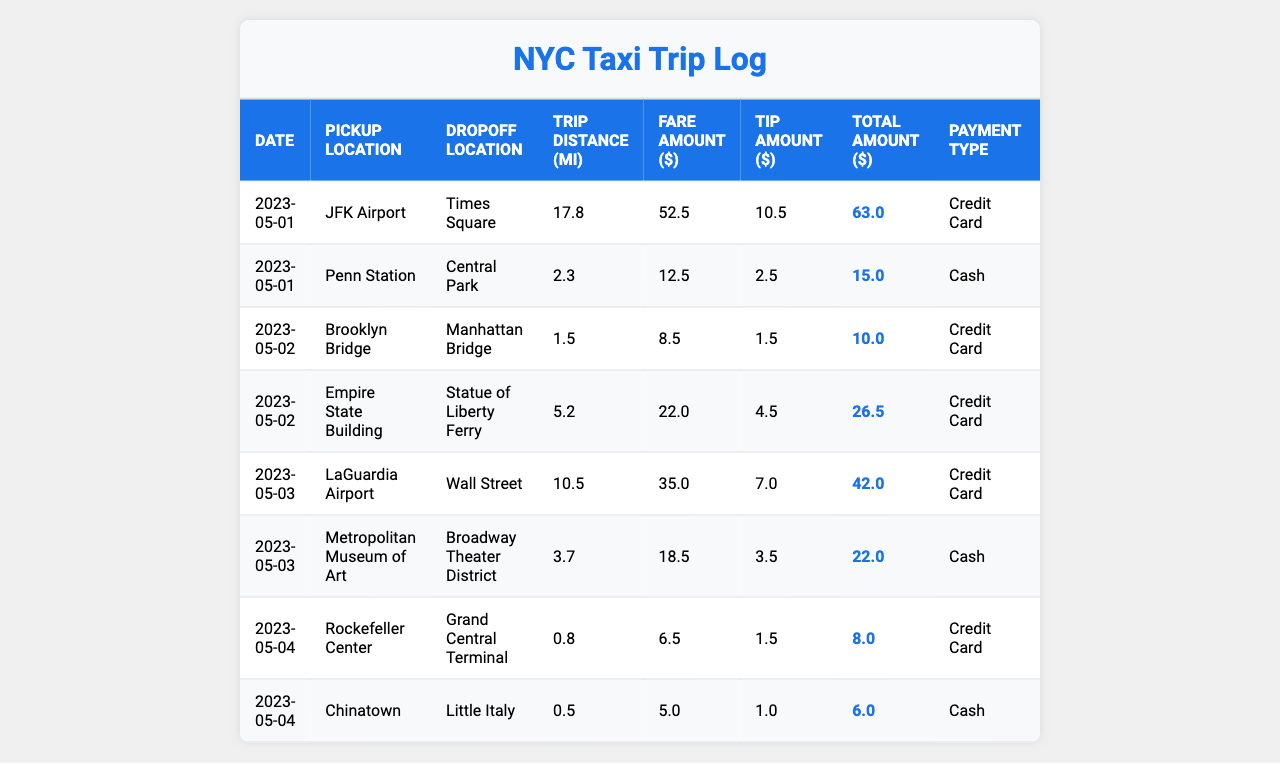What was the total fare amount collected on May 1, 2023? On May 1, the two trips had fare amounts of $52.5 and $12.5. Adding these amounts, we get $52.5 + $12.5 = $65.0.
Answer: $65.0 What was the longest trip duration recorded? The trip durations listed are 45, 15, 10, 25, 30, 20, 8, and 5 minutes. The longest duration is 45 minutes.
Answer: 45 minutes How much tip was earned for the trip from LaGuardia Airport to Wall Street? The trip from LaGuardia Airport to Wall Street had a tip amount of $7.0.
Answer: $7.0 Did any trip on May 3, 2023, have a passenger count of more than 2? On May 3, there were two trips; one had 1 passenger and the other had 2 passengers. Thus, none had more than 2 passengers.
Answer: No What was the total amount earned from trips on May 2, 2023? On May 2, the total amounts for the two trips were $10.0 and $26.5. Adding these, $10.0 + $26.5 = $36.5.
Answer: $36.5 Which payment type was used for the trip from Chinatown to Little Italy? The payment type for the trip from Chinatown to Little Italy was Cash.
Answer: Cash Calculate the average trip distance for all trips recorded. The trip distances are 17.8, 2.3, 1.5, 5.2, 10.5, 3.7, 0.8, and 0.5 miles. Sum them to get 42.8 miles. There are 8 trips, so the average distance is 42.8 / 8 = 5.35 miles.
Answer: 5.35 miles Was there any trip with a tip amount greater than $5? The trip from JFK Airport to Times Square had a tip of $10.5 and the trip from LaGuardia Airport to Wall Street had a tip of $7.0. Thus, yes, there were trips with tips greater than $5.
Answer: Yes Which dropoff location had the highest total amount earned? The trip from JFK Airport to Times Square had a total amount of $63.0 while the trip from Empire State to Statue of Liberty Ferry earned $26.5. The highest is $63.0 from JFK to Times Square.
Answer: JFK Airport What was the overall total amount earned by the taxi driver across all recorded trips? Adding the total amounts: $63.0 + $15.0 + $10.0 + $26.5 + $42.0 + $22.0 + $8.0 + $6.0 gives a total of $192.5.
Answer: $192.5 